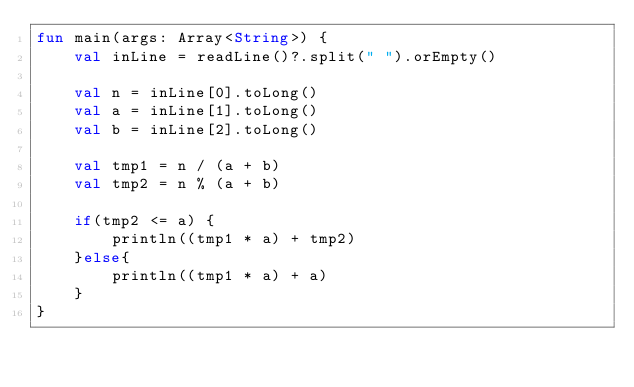<code> <loc_0><loc_0><loc_500><loc_500><_Kotlin_>fun main(args: Array<String>) {
    val inLine = readLine()?.split(" ").orEmpty()

    val n = inLine[0].toLong()
    val a = inLine[1].toLong()
    val b = inLine[2].toLong()

    val tmp1 = n / (a + b)
    val tmp2 = n % (a + b)

    if(tmp2 <= a) {
        println((tmp1 * a) + tmp2)
    }else{
        println((tmp1 * a) + a)
    }
}</code> 